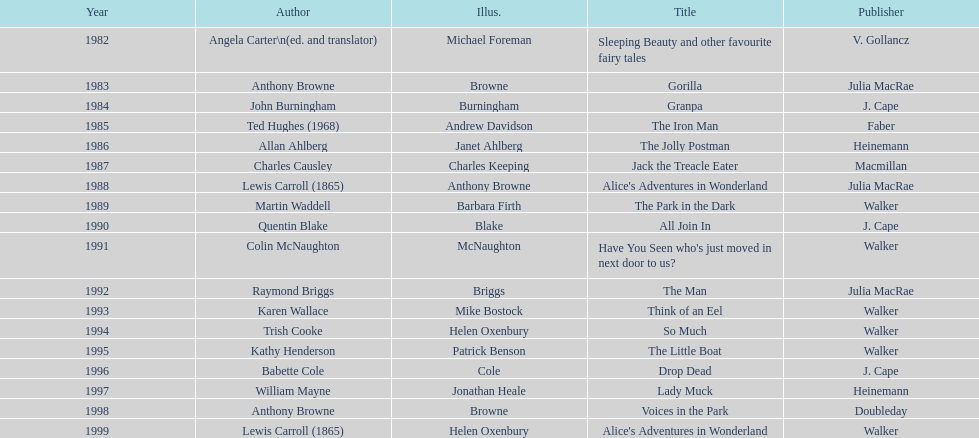How many titles did walker publish? 6. 